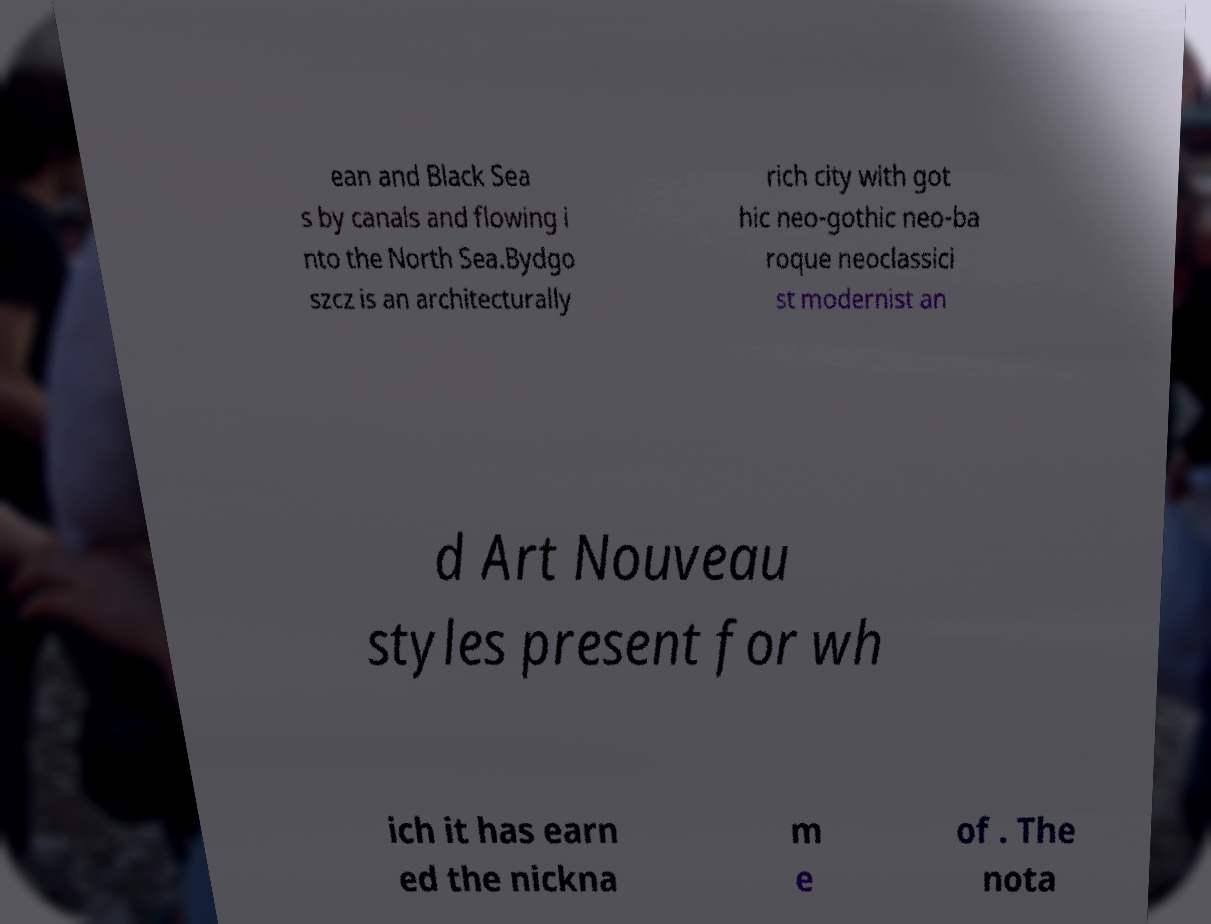Could you extract and type out the text from this image? ean and Black Sea s by canals and flowing i nto the North Sea.Bydgo szcz is an architecturally rich city with got hic neo-gothic neo-ba roque neoclassici st modernist an d Art Nouveau styles present for wh ich it has earn ed the nickna m e of . The nota 